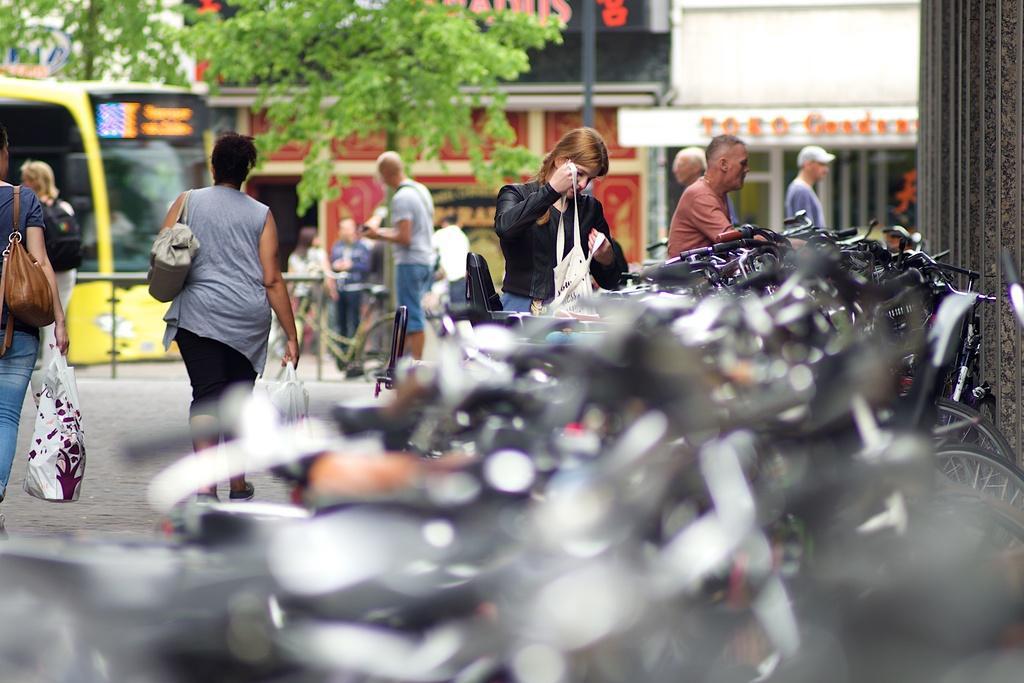Could you give a brief overview of what you see in this image? In this image we can see people standing on the ground, some woman is carrying bags and holding covers in their hands. To the left side we can see a group of bicycles parked on the ground. In the background, we can see a group of buildings with sign boards, poles, trees and a bus placed on the ground. 